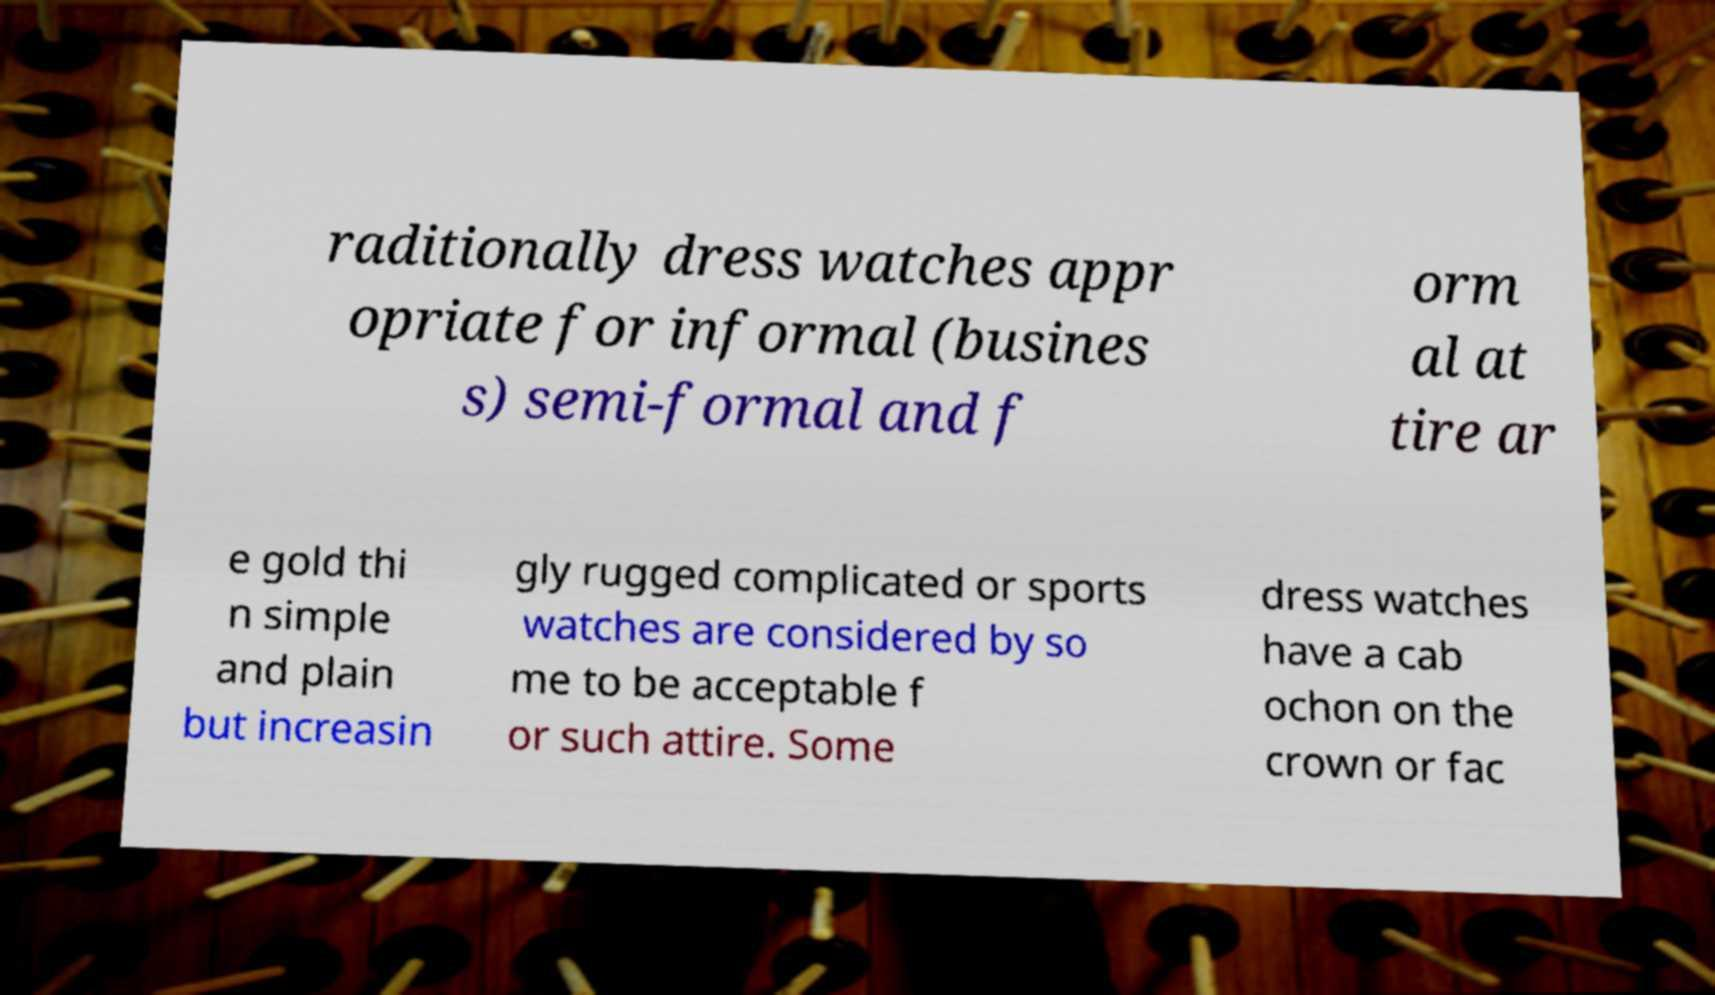Please identify and transcribe the text found in this image. raditionally dress watches appr opriate for informal (busines s) semi-formal and f orm al at tire ar e gold thi n simple and plain but increasin gly rugged complicated or sports watches are considered by so me to be acceptable f or such attire. Some dress watches have a cab ochon on the crown or fac 